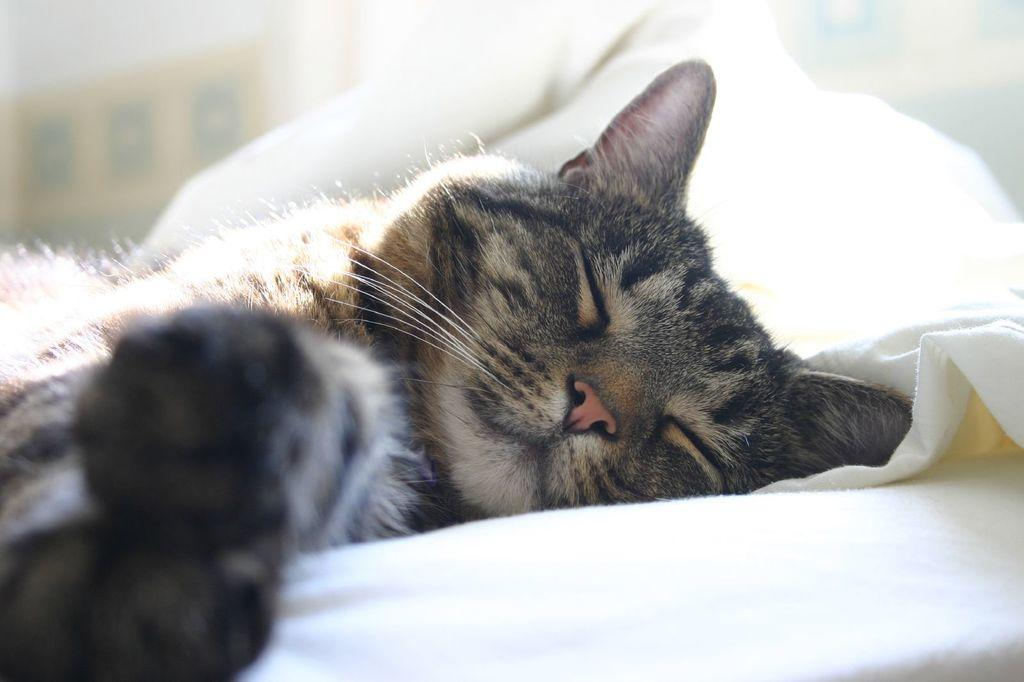What type of animal is in the image? There is a cat in the image. What is the cat lying on? The cat is lying on a cloth. What type of liquid can be seen coming out of the cat's mouth in the image? There is no liquid coming out of the cat's mouth in the image. What type of voice does the cat have in the image? The image is a still picture, so there is no sound or voice present. 